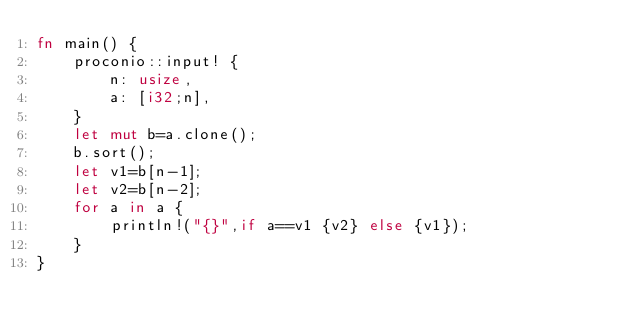Convert code to text. <code><loc_0><loc_0><loc_500><loc_500><_Rust_>fn main() {
    proconio::input! {
        n: usize,
        a: [i32;n],
    }
    let mut b=a.clone();
    b.sort();
    let v1=b[n-1];
    let v2=b[n-2];
    for a in a {
        println!("{}",if a==v1 {v2} else {v1});
    }
}</code> 